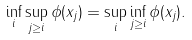Convert formula to latex. <formula><loc_0><loc_0><loc_500><loc_500>\inf _ { i } \sup _ { j \geq i } \phi ( x _ { j } ) = \sup _ { i } \inf _ { j \geq i } \phi ( x _ { j } ) .</formula> 